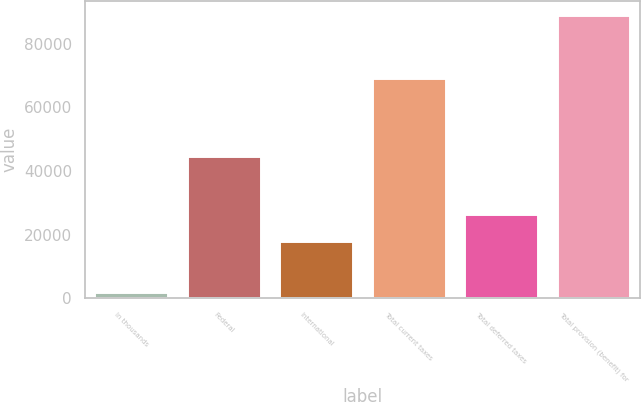Convert chart to OTSL. <chart><loc_0><loc_0><loc_500><loc_500><bar_chart><fcel>In thousands<fcel>Federal<fcel>International<fcel>Total current taxes<fcel>Total deferred taxes<fcel>Total provision (benefit) for<nl><fcel>2010<fcel>44766<fcel>17877<fcel>69234<fcel>26570.3<fcel>88943<nl></chart> 